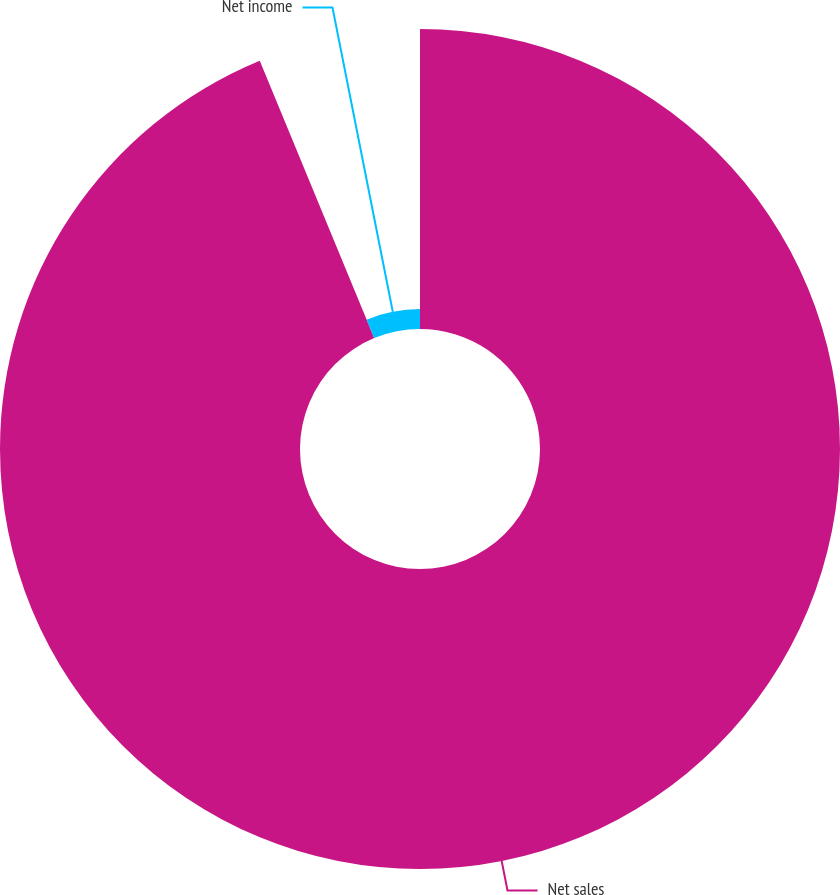<chart> <loc_0><loc_0><loc_500><loc_500><pie_chart><fcel>Net sales<fcel>Net income<nl><fcel>93.77%<fcel>6.23%<nl></chart> 